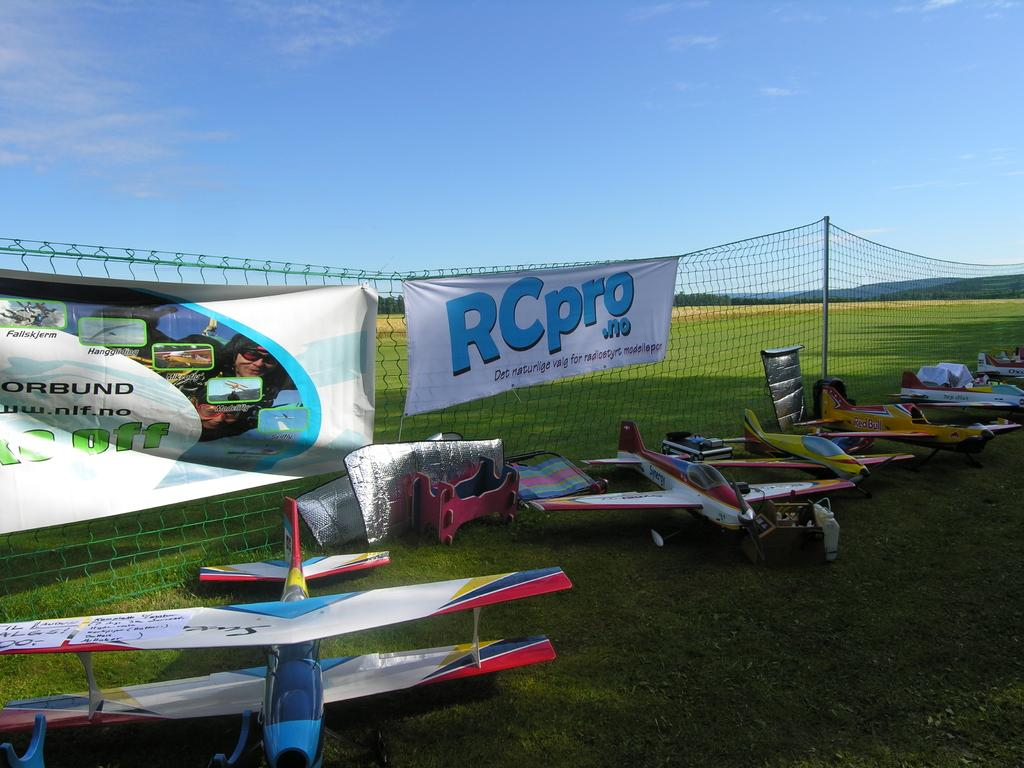<image>
Describe the image concisely. a sign outside that says RCpro on it 